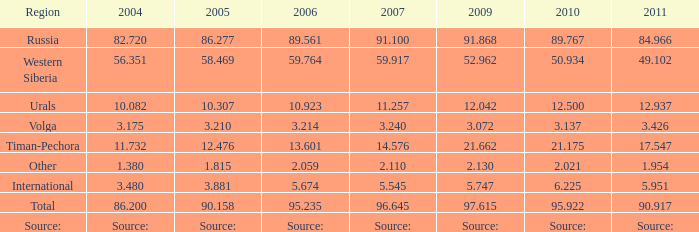What is the 2010 Lukoil oil prodroduction when in 2009 oil production 21.662 million tonnes? 21.175. 